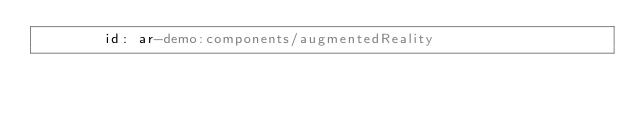<code> <loc_0><loc_0><loc_500><loc_500><_YAML_>        id: ar-demo:components/augmentedReality
</code> 